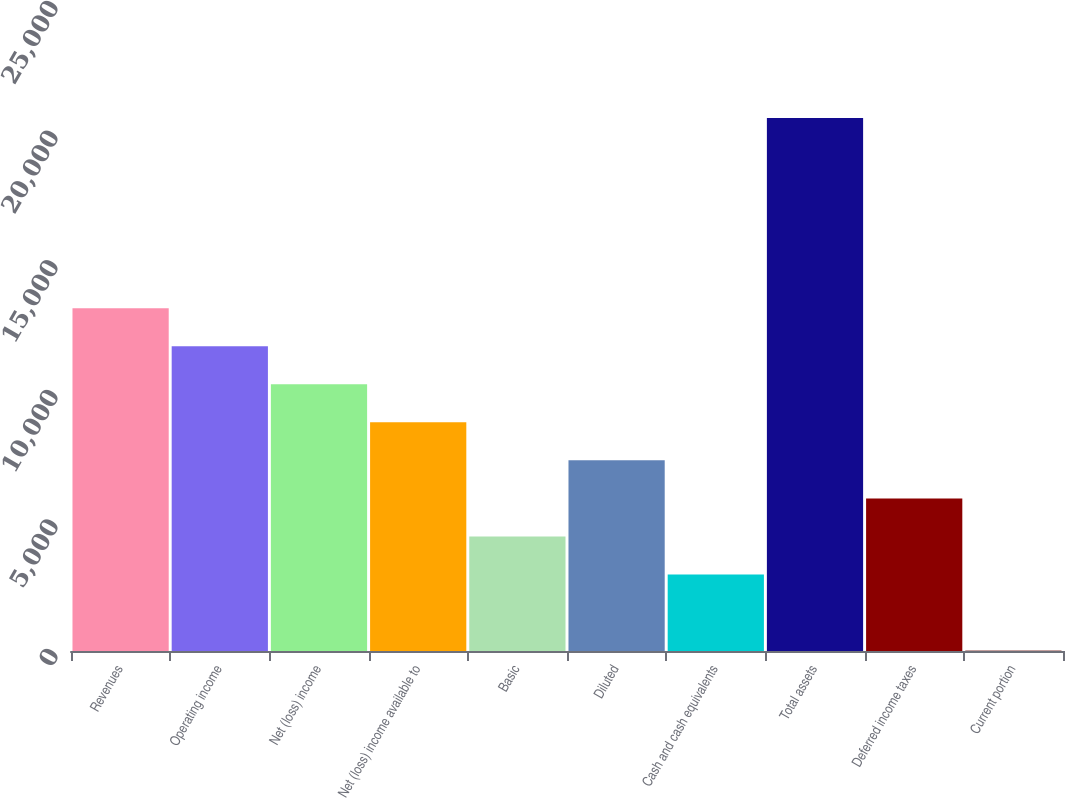<chart> <loc_0><loc_0><loc_500><loc_500><bar_chart><fcel>Revenues<fcel>Operating income<fcel>Net (loss) income<fcel>Net (loss) income available to<fcel>Basic<fcel>Diluted<fcel>Cash and cash equivalents<fcel>Total assets<fcel>Deferred income taxes<fcel>Current portion<nl><fcel>13225.4<fcel>11757.8<fcel>10290.2<fcel>8822.6<fcel>4419.8<fcel>7355<fcel>2952.2<fcel>20563.4<fcel>5887.4<fcel>17<nl></chart> 